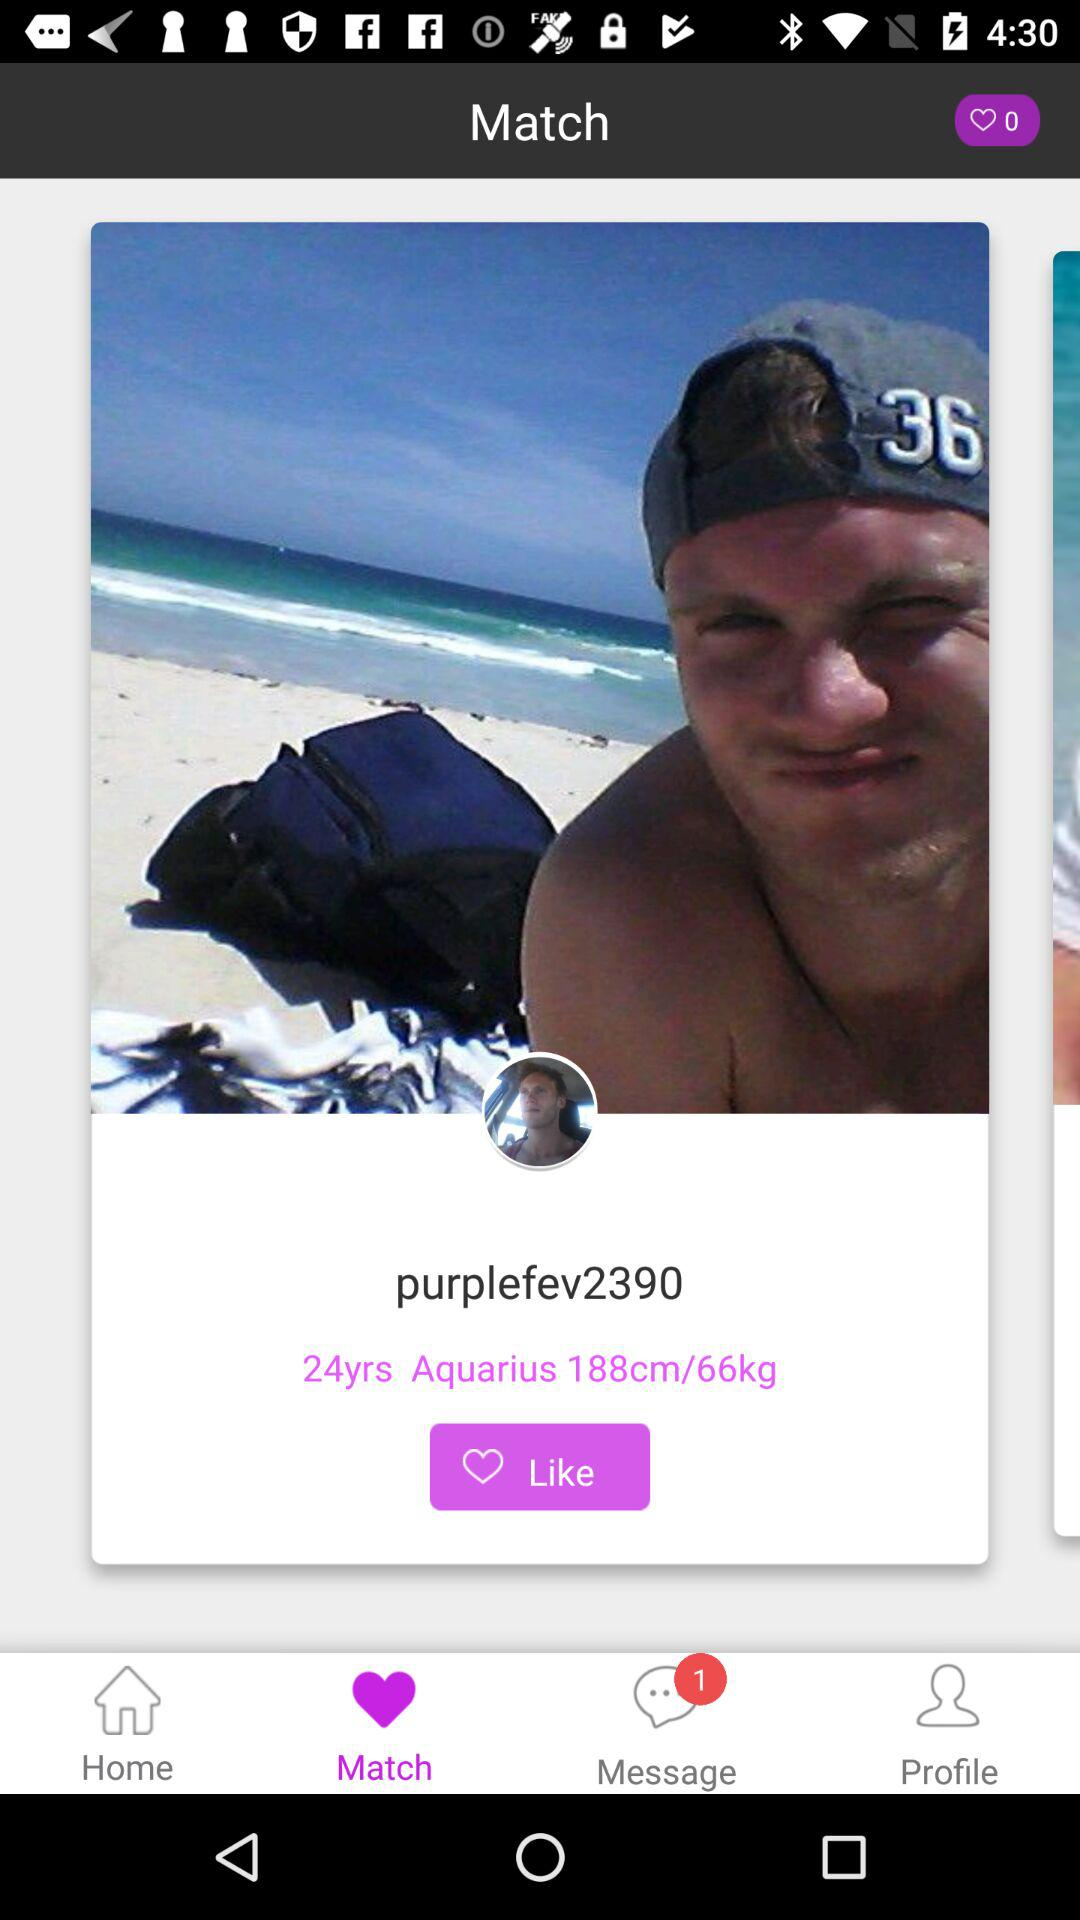What is the selected tab? The selected tab is "Match". 